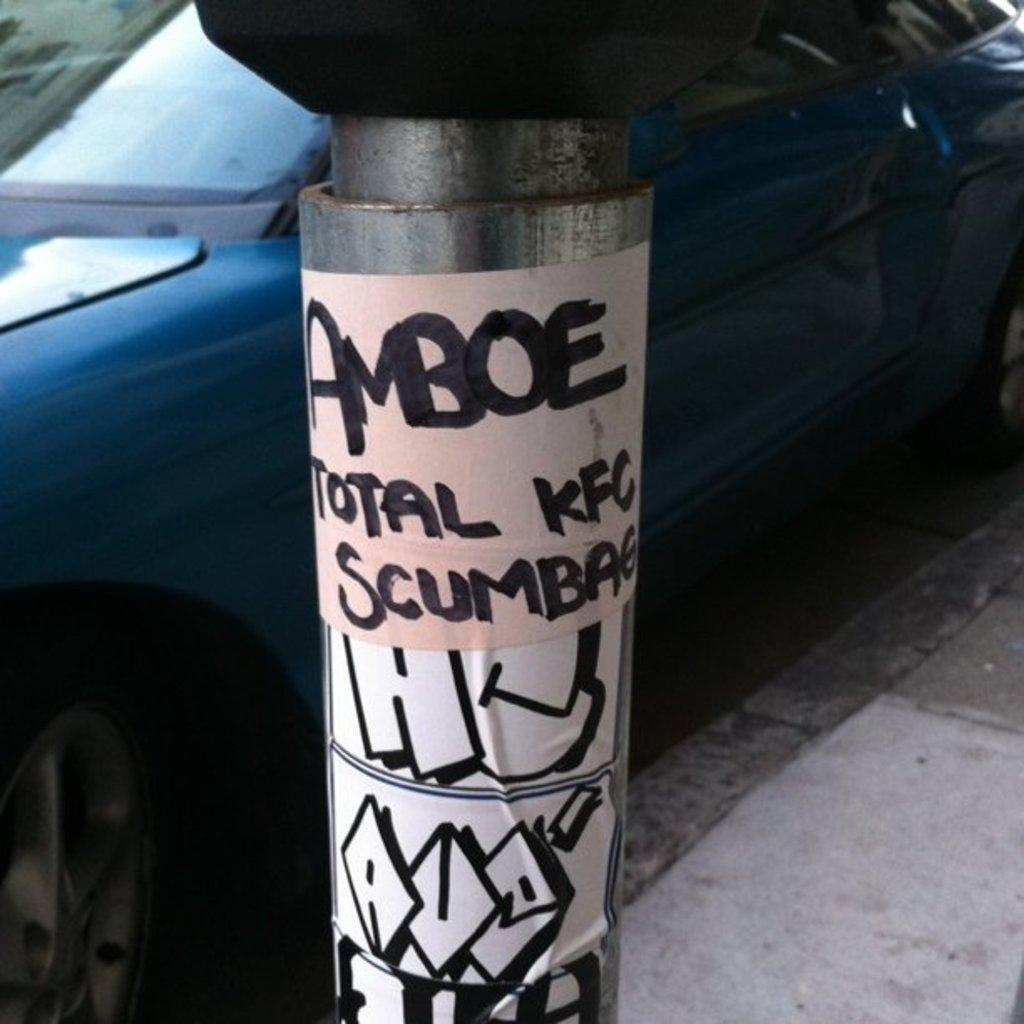What is the main object in the image? There is a pole in the image. What is attached to the pole? Papers are attached to the pole. What can be seen on the papers? There is writing on the papers. What can be seen in the background of the image? There is a blue car in the background of the image. How many apples are hanging from the pole in the image? There are no apples present in the image; only papers are attached to the pole. What type of sticks are used to hold the papers on the pole? There are no sticks visible in the image; the papers are simply attached to the pole. 